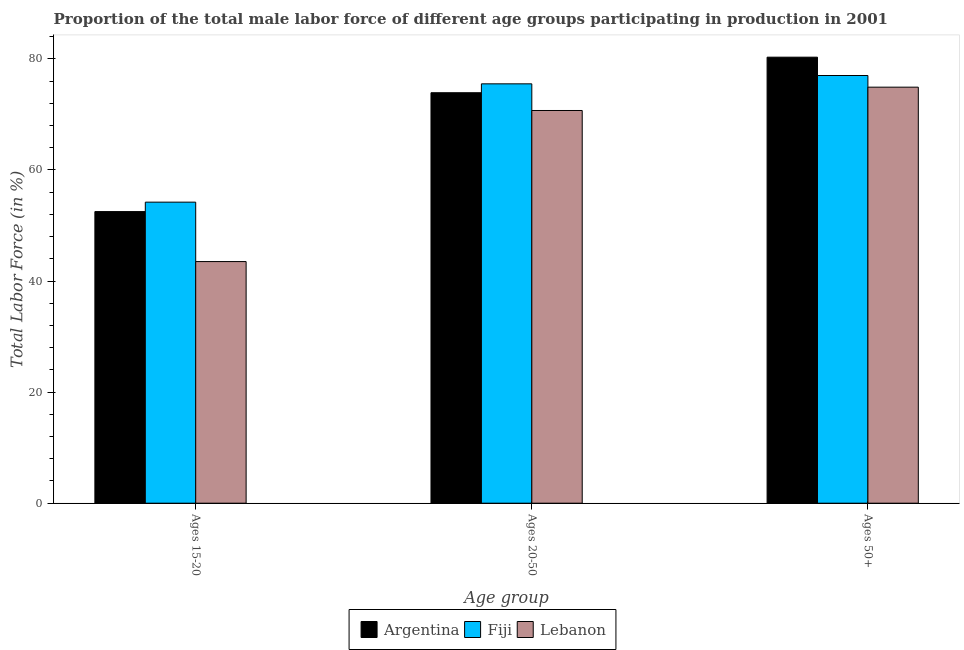How many different coloured bars are there?
Keep it short and to the point. 3. Are the number of bars on each tick of the X-axis equal?
Ensure brevity in your answer.  Yes. What is the label of the 2nd group of bars from the left?
Make the answer very short. Ages 20-50. What is the percentage of male labor force within the age group 15-20 in Fiji?
Offer a very short reply. 54.2. Across all countries, what is the maximum percentage of male labor force within the age group 20-50?
Your response must be concise. 75.5. Across all countries, what is the minimum percentage of male labor force within the age group 20-50?
Give a very brief answer. 70.7. In which country was the percentage of male labor force within the age group 15-20 maximum?
Provide a short and direct response. Fiji. In which country was the percentage of male labor force within the age group 15-20 minimum?
Your answer should be compact. Lebanon. What is the total percentage of male labor force within the age group 15-20 in the graph?
Keep it short and to the point. 150.2. What is the difference between the percentage of male labor force within the age group 20-50 in Argentina and that in Lebanon?
Provide a succinct answer. 3.2. What is the difference between the percentage of male labor force above age 50 in Argentina and the percentage of male labor force within the age group 20-50 in Fiji?
Your response must be concise. 4.8. What is the average percentage of male labor force within the age group 20-50 per country?
Make the answer very short. 73.37. What is the difference between the percentage of male labor force above age 50 and percentage of male labor force within the age group 20-50 in Argentina?
Provide a succinct answer. 6.4. What is the ratio of the percentage of male labor force above age 50 in Lebanon to that in Fiji?
Ensure brevity in your answer.  0.97. Is the percentage of male labor force within the age group 20-50 in Lebanon less than that in Argentina?
Offer a terse response. Yes. What is the difference between the highest and the second highest percentage of male labor force within the age group 20-50?
Give a very brief answer. 1.6. What is the difference between the highest and the lowest percentage of male labor force above age 50?
Offer a very short reply. 5.4. In how many countries, is the percentage of male labor force within the age group 15-20 greater than the average percentage of male labor force within the age group 15-20 taken over all countries?
Your response must be concise. 2. What does the 3rd bar from the left in Ages 20-50 represents?
Your answer should be very brief. Lebanon. What does the 1st bar from the right in Ages 20-50 represents?
Provide a succinct answer. Lebanon. Is it the case that in every country, the sum of the percentage of male labor force within the age group 15-20 and percentage of male labor force within the age group 20-50 is greater than the percentage of male labor force above age 50?
Your answer should be very brief. Yes. How many bars are there?
Give a very brief answer. 9. Are all the bars in the graph horizontal?
Give a very brief answer. No. How many countries are there in the graph?
Give a very brief answer. 3. Does the graph contain any zero values?
Your response must be concise. No. How are the legend labels stacked?
Ensure brevity in your answer.  Horizontal. What is the title of the graph?
Make the answer very short. Proportion of the total male labor force of different age groups participating in production in 2001. Does "Nigeria" appear as one of the legend labels in the graph?
Your answer should be very brief. No. What is the label or title of the X-axis?
Your response must be concise. Age group. What is the label or title of the Y-axis?
Offer a very short reply. Total Labor Force (in %). What is the Total Labor Force (in %) of Argentina in Ages 15-20?
Provide a short and direct response. 52.5. What is the Total Labor Force (in %) of Fiji in Ages 15-20?
Give a very brief answer. 54.2. What is the Total Labor Force (in %) in Lebanon in Ages 15-20?
Your answer should be very brief. 43.5. What is the Total Labor Force (in %) in Argentina in Ages 20-50?
Give a very brief answer. 73.9. What is the Total Labor Force (in %) in Fiji in Ages 20-50?
Give a very brief answer. 75.5. What is the Total Labor Force (in %) in Lebanon in Ages 20-50?
Your answer should be compact. 70.7. What is the Total Labor Force (in %) in Argentina in Ages 50+?
Give a very brief answer. 80.3. What is the Total Labor Force (in %) in Lebanon in Ages 50+?
Make the answer very short. 74.9. Across all Age group, what is the maximum Total Labor Force (in %) of Argentina?
Your answer should be very brief. 80.3. Across all Age group, what is the maximum Total Labor Force (in %) in Lebanon?
Make the answer very short. 74.9. Across all Age group, what is the minimum Total Labor Force (in %) of Argentina?
Make the answer very short. 52.5. Across all Age group, what is the minimum Total Labor Force (in %) in Fiji?
Your response must be concise. 54.2. Across all Age group, what is the minimum Total Labor Force (in %) in Lebanon?
Keep it short and to the point. 43.5. What is the total Total Labor Force (in %) of Argentina in the graph?
Keep it short and to the point. 206.7. What is the total Total Labor Force (in %) in Fiji in the graph?
Give a very brief answer. 206.7. What is the total Total Labor Force (in %) in Lebanon in the graph?
Your answer should be compact. 189.1. What is the difference between the Total Labor Force (in %) in Argentina in Ages 15-20 and that in Ages 20-50?
Offer a terse response. -21.4. What is the difference between the Total Labor Force (in %) of Fiji in Ages 15-20 and that in Ages 20-50?
Provide a short and direct response. -21.3. What is the difference between the Total Labor Force (in %) of Lebanon in Ages 15-20 and that in Ages 20-50?
Give a very brief answer. -27.2. What is the difference between the Total Labor Force (in %) of Argentina in Ages 15-20 and that in Ages 50+?
Give a very brief answer. -27.8. What is the difference between the Total Labor Force (in %) in Fiji in Ages 15-20 and that in Ages 50+?
Make the answer very short. -22.8. What is the difference between the Total Labor Force (in %) of Lebanon in Ages 15-20 and that in Ages 50+?
Give a very brief answer. -31.4. What is the difference between the Total Labor Force (in %) of Lebanon in Ages 20-50 and that in Ages 50+?
Offer a terse response. -4.2. What is the difference between the Total Labor Force (in %) in Argentina in Ages 15-20 and the Total Labor Force (in %) in Lebanon in Ages 20-50?
Your answer should be very brief. -18.2. What is the difference between the Total Labor Force (in %) in Fiji in Ages 15-20 and the Total Labor Force (in %) in Lebanon in Ages 20-50?
Offer a very short reply. -16.5. What is the difference between the Total Labor Force (in %) of Argentina in Ages 15-20 and the Total Labor Force (in %) of Fiji in Ages 50+?
Provide a short and direct response. -24.5. What is the difference between the Total Labor Force (in %) of Argentina in Ages 15-20 and the Total Labor Force (in %) of Lebanon in Ages 50+?
Keep it short and to the point. -22.4. What is the difference between the Total Labor Force (in %) in Fiji in Ages 15-20 and the Total Labor Force (in %) in Lebanon in Ages 50+?
Provide a short and direct response. -20.7. What is the difference between the Total Labor Force (in %) of Argentina in Ages 20-50 and the Total Labor Force (in %) of Lebanon in Ages 50+?
Offer a terse response. -1. What is the difference between the Total Labor Force (in %) of Fiji in Ages 20-50 and the Total Labor Force (in %) of Lebanon in Ages 50+?
Keep it short and to the point. 0.6. What is the average Total Labor Force (in %) of Argentina per Age group?
Give a very brief answer. 68.9. What is the average Total Labor Force (in %) in Fiji per Age group?
Provide a succinct answer. 68.9. What is the average Total Labor Force (in %) of Lebanon per Age group?
Your answer should be compact. 63.03. What is the difference between the Total Labor Force (in %) of Argentina and Total Labor Force (in %) of Fiji in Ages 20-50?
Provide a short and direct response. -1.6. What is the difference between the Total Labor Force (in %) in Argentina and Total Labor Force (in %) in Lebanon in Ages 50+?
Your answer should be compact. 5.4. What is the ratio of the Total Labor Force (in %) in Argentina in Ages 15-20 to that in Ages 20-50?
Provide a succinct answer. 0.71. What is the ratio of the Total Labor Force (in %) in Fiji in Ages 15-20 to that in Ages 20-50?
Keep it short and to the point. 0.72. What is the ratio of the Total Labor Force (in %) in Lebanon in Ages 15-20 to that in Ages 20-50?
Provide a succinct answer. 0.62. What is the ratio of the Total Labor Force (in %) of Argentina in Ages 15-20 to that in Ages 50+?
Keep it short and to the point. 0.65. What is the ratio of the Total Labor Force (in %) in Fiji in Ages 15-20 to that in Ages 50+?
Offer a terse response. 0.7. What is the ratio of the Total Labor Force (in %) of Lebanon in Ages 15-20 to that in Ages 50+?
Your answer should be compact. 0.58. What is the ratio of the Total Labor Force (in %) in Argentina in Ages 20-50 to that in Ages 50+?
Keep it short and to the point. 0.92. What is the ratio of the Total Labor Force (in %) in Fiji in Ages 20-50 to that in Ages 50+?
Make the answer very short. 0.98. What is the ratio of the Total Labor Force (in %) in Lebanon in Ages 20-50 to that in Ages 50+?
Your answer should be compact. 0.94. What is the difference between the highest and the second highest Total Labor Force (in %) in Argentina?
Give a very brief answer. 6.4. What is the difference between the highest and the second highest Total Labor Force (in %) of Lebanon?
Offer a terse response. 4.2. What is the difference between the highest and the lowest Total Labor Force (in %) in Argentina?
Provide a short and direct response. 27.8. What is the difference between the highest and the lowest Total Labor Force (in %) in Fiji?
Provide a succinct answer. 22.8. What is the difference between the highest and the lowest Total Labor Force (in %) in Lebanon?
Your response must be concise. 31.4. 